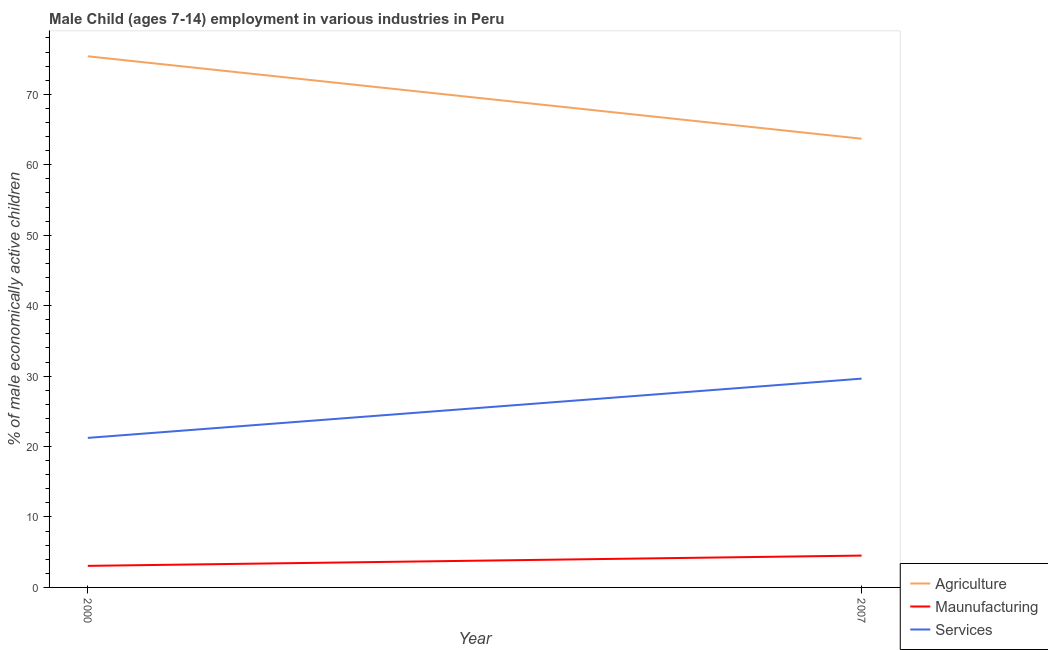How many different coloured lines are there?
Your response must be concise. 3. Does the line corresponding to percentage of economically active children in agriculture intersect with the line corresponding to percentage of economically active children in services?
Keep it short and to the point. No. Is the number of lines equal to the number of legend labels?
Ensure brevity in your answer.  Yes. What is the percentage of economically active children in manufacturing in 2000?
Ensure brevity in your answer.  3.06. Across all years, what is the maximum percentage of economically active children in manufacturing?
Provide a succinct answer. 4.52. Across all years, what is the minimum percentage of economically active children in services?
Your response must be concise. 21.23. In which year was the percentage of economically active children in agriculture minimum?
Provide a succinct answer. 2007. What is the total percentage of economically active children in services in the graph?
Make the answer very short. 50.87. What is the difference between the percentage of economically active children in agriculture in 2000 and that in 2007?
Give a very brief answer. 11.7. What is the difference between the percentage of economically active children in agriculture in 2007 and the percentage of economically active children in services in 2000?
Keep it short and to the point. 42.47. What is the average percentage of economically active children in manufacturing per year?
Provide a succinct answer. 3.79. In the year 2000, what is the difference between the percentage of economically active children in manufacturing and percentage of economically active children in agriculture?
Offer a terse response. -72.34. In how many years, is the percentage of economically active children in agriculture greater than 20 %?
Provide a short and direct response. 2. What is the ratio of the percentage of economically active children in manufacturing in 2000 to that in 2007?
Provide a short and direct response. 0.68. In how many years, is the percentage of economically active children in services greater than the average percentage of economically active children in services taken over all years?
Provide a succinct answer. 1. Is it the case that in every year, the sum of the percentage of economically active children in agriculture and percentage of economically active children in manufacturing is greater than the percentage of economically active children in services?
Ensure brevity in your answer.  Yes. Does the percentage of economically active children in services monotonically increase over the years?
Your answer should be very brief. Yes. Is the percentage of economically active children in agriculture strictly greater than the percentage of economically active children in manufacturing over the years?
Keep it short and to the point. Yes. Is the percentage of economically active children in agriculture strictly less than the percentage of economically active children in services over the years?
Your answer should be compact. No. How many lines are there?
Offer a terse response. 3. How many years are there in the graph?
Keep it short and to the point. 2. Does the graph contain any zero values?
Keep it short and to the point. No. What is the title of the graph?
Provide a short and direct response. Male Child (ages 7-14) employment in various industries in Peru. Does "Tertiary" appear as one of the legend labels in the graph?
Ensure brevity in your answer.  No. What is the label or title of the Y-axis?
Provide a succinct answer. % of male economically active children. What is the % of male economically active children of Agriculture in 2000?
Your answer should be compact. 75.4. What is the % of male economically active children in Maunufacturing in 2000?
Keep it short and to the point. 3.06. What is the % of male economically active children in Services in 2000?
Give a very brief answer. 21.23. What is the % of male economically active children in Agriculture in 2007?
Offer a very short reply. 63.7. What is the % of male economically active children in Maunufacturing in 2007?
Keep it short and to the point. 4.52. What is the % of male economically active children of Services in 2007?
Provide a succinct answer. 29.64. Across all years, what is the maximum % of male economically active children in Agriculture?
Provide a succinct answer. 75.4. Across all years, what is the maximum % of male economically active children in Maunufacturing?
Ensure brevity in your answer.  4.52. Across all years, what is the maximum % of male economically active children of Services?
Your answer should be very brief. 29.64. Across all years, what is the minimum % of male economically active children of Agriculture?
Provide a short and direct response. 63.7. Across all years, what is the minimum % of male economically active children of Maunufacturing?
Ensure brevity in your answer.  3.06. Across all years, what is the minimum % of male economically active children of Services?
Your answer should be compact. 21.23. What is the total % of male economically active children in Agriculture in the graph?
Offer a terse response. 139.1. What is the total % of male economically active children of Maunufacturing in the graph?
Offer a terse response. 7.58. What is the total % of male economically active children in Services in the graph?
Offer a very short reply. 50.87. What is the difference between the % of male economically active children in Maunufacturing in 2000 and that in 2007?
Provide a short and direct response. -1.46. What is the difference between the % of male economically active children in Services in 2000 and that in 2007?
Provide a succinct answer. -8.41. What is the difference between the % of male economically active children of Agriculture in 2000 and the % of male economically active children of Maunufacturing in 2007?
Offer a terse response. 70.88. What is the difference between the % of male economically active children in Agriculture in 2000 and the % of male economically active children in Services in 2007?
Provide a short and direct response. 45.76. What is the difference between the % of male economically active children of Maunufacturing in 2000 and the % of male economically active children of Services in 2007?
Your response must be concise. -26.58. What is the average % of male economically active children of Agriculture per year?
Ensure brevity in your answer.  69.55. What is the average % of male economically active children in Maunufacturing per year?
Make the answer very short. 3.79. What is the average % of male economically active children in Services per year?
Ensure brevity in your answer.  25.43. In the year 2000, what is the difference between the % of male economically active children in Agriculture and % of male economically active children in Maunufacturing?
Make the answer very short. 72.34. In the year 2000, what is the difference between the % of male economically active children of Agriculture and % of male economically active children of Services?
Your response must be concise. 54.17. In the year 2000, what is the difference between the % of male economically active children of Maunufacturing and % of male economically active children of Services?
Make the answer very short. -18.17. In the year 2007, what is the difference between the % of male economically active children in Agriculture and % of male economically active children in Maunufacturing?
Give a very brief answer. 59.18. In the year 2007, what is the difference between the % of male economically active children in Agriculture and % of male economically active children in Services?
Give a very brief answer. 34.06. In the year 2007, what is the difference between the % of male economically active children in Maunufacturing and % of male economically active children in Services?
Provide a succinct answer. -25.12. What is the ratio of the % of male economically active children of Agriculture in 2000 to that in 2007?
Your answer should be very brief. 1.18. What is the ratio of the % of male economically active children in Maunufacturing in 2000 to that in 2007?
Your answer should be compact. 0.68. What is the ratio of the % of male economically active children of Services in 2000 to that in 2007?
Provide a succinct answer. 0.72. What is the difference between the highest and the second highest % of male economically active children in Maunufacturing?
Provide a short and direct response. 1.46. What is the difference between the highest and the second highest % of male economically active children in Services?
Offer a terse response. 8.41. What is the difference between the highest and the lowest % of male economically active children of Agriculture?
Ensure brevity in your answer.  11.7. What is the difference between the highest and the lowest % of male economically active children of Maunufacturing?
Offer a terse response. 1.46. What is the difference between the highest and the lowest % of male economically active children in Services?
Keep it short and to the point. 8.41. 